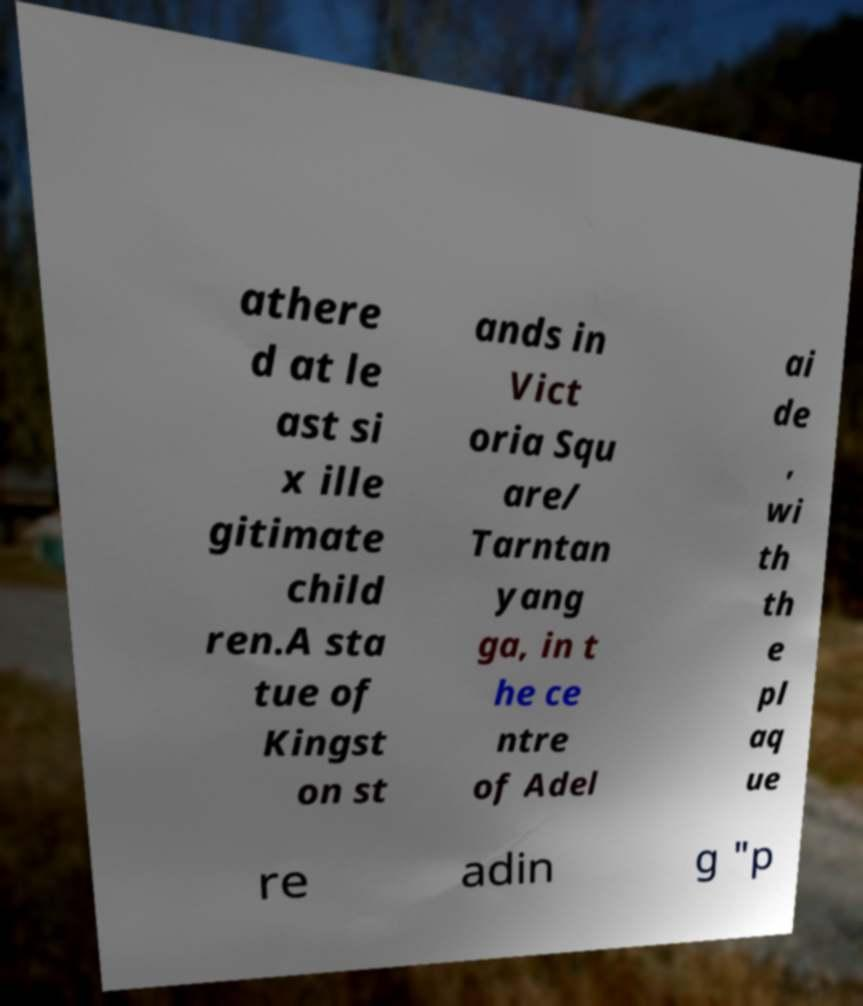What messages or text are displayed in this image? I need them in a readable, typed format. athere d at le ast si x ille gitimate child ren.A sta tue of Kingst on st ands in Vict oria Squ are/ Tarntan yang ga, in t he ce ntre of Adel ai de , wi th th e pl aq ue re adin g "p 